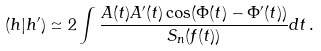<formula> <loc_0><loc_0><loc_500><loc_500>( h | h ^ { \prime } ) \simeq 2 \int \frac { A ( t ) A ^ { \prime } ( t ) \cos ( \Phi ( t ) - \Phi ^ { \prime } ( t ) ) } { S _ { n } ( f ( t ) ) } d t \, .</formula> 